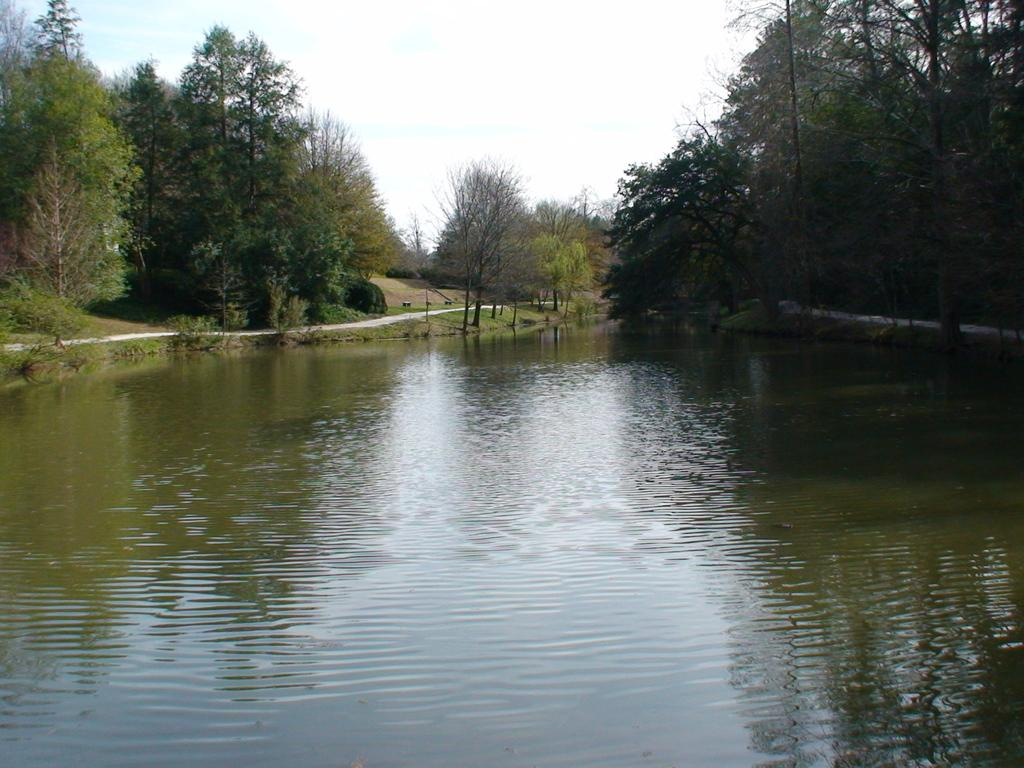What type of vegetation can be seen in the image? There are trees in the image. What else can be seen on the ground in the image? There is grass in the image. What is visible in the background of the image? The sky is visible in the background of the image. What is present at the bottom of the image? There is water at the bottom of the image. What can be observed on the water's surface? There are reflections on the water. How many wings can be seen on the bee in the image? There is no bee present in the image, so it is not possible to determine the number of wings. 